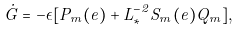Convert formula to latex. <formula><loc_0><loc_0><loc_500><loc_500>\dot { G } = - \epsilon [ P _ { m } ( e ) + L _ { * } ^ { - 2 } S _ { m } ( e ) Q _ { m } ] ,</formula> 